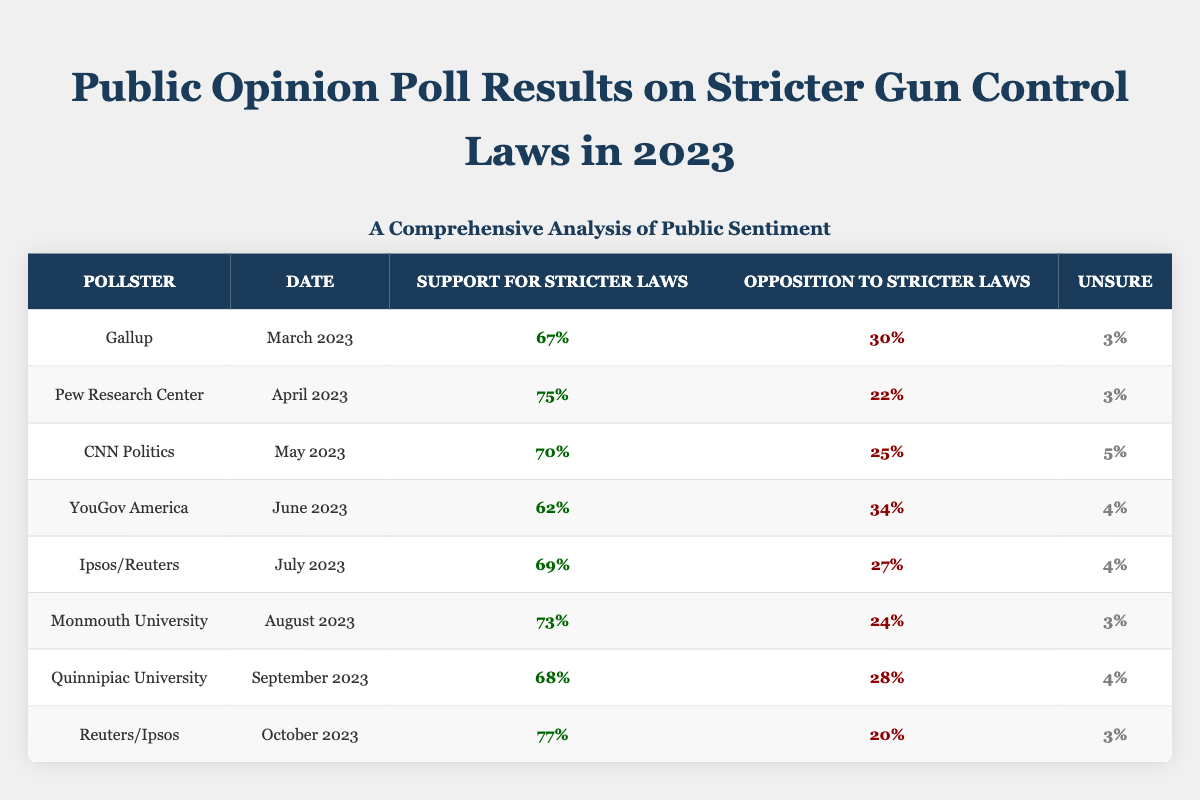What percentage of respondents supported stricter gun control laws according to The Pew Research Center in April 2023? The table shows that the support for stricter laws by Pew Research Center in April 2023 is directly listed as 75%.
Answer: 75% Which pollster recorded the lowest support for stricter gun control laws in 2023? By looking at the support percentages in the table, YouGov America recorded the lowest support at 62% in June 2023.
Answer: YouGov America What is the total percentage of opposition to stricter laws across all the polls listed? The opposition percentages are 30% + 22% + 25% + 34% + 27% + 24% + 28% + 20% = 210%. Thus, the total opposition across all polls is 210%.
Answer: 210% Which month showed the highest support for stricter gun control laws and what was that percentage? From the table, the highest support is 77%, recorded by Reuters/Ipsos in October 2023.
Answer: 77% Is it true that more than 70% of respondents supported stricter laws in March 2023? The table indicates that the support in March 2023 was 67%, which is not more than 70%.
Answer: No What is the average support for stricter gun control laws across all polls listed? To find the average support, sum the percentages: 67 + 75 + 70 + 62 + 69 + 73 + 68 + 77 = 591% and divide by 8 (the number of polls), resulting in an average of 73.875%.
Answer: 73.875% How many polls reported support for stricter laws of at least 70%? By examining the table, the polls with at least 70% support are: Pew Research Center (75%), CNN Politics (70%), Ipsos/Reuters (69% but not included), Monmouth University (73%), Quinnipiac University (68% but not included), and Reuters/Ipsos (77%). That gives a total of 5 polls.
Answer: 5 What percentage of respondents were unsure about stricter laws in August 2023? The table indicates that the percentage of respondents unsure in August 2023 was 3% as reflected in Monmouth University’s report.
Answer: 3% Which two months had an opposition percentage of 30% or higher, and what were those percentages? The two months which had an opposition percentage of 30% or higher are YouGov America (34% in June) and Ipsos/Reuters (27% in July, but not meeting the criteria), with only YouGov America qualifying.
Answer: YouGov America (34%) What was the difference in support for stricter laws between the highest recorded (October 2023) and the lowest recorded (June 2023)? The difference is calculated as 77% (October) - 62% (June) = 15%.
Answer: 15% 